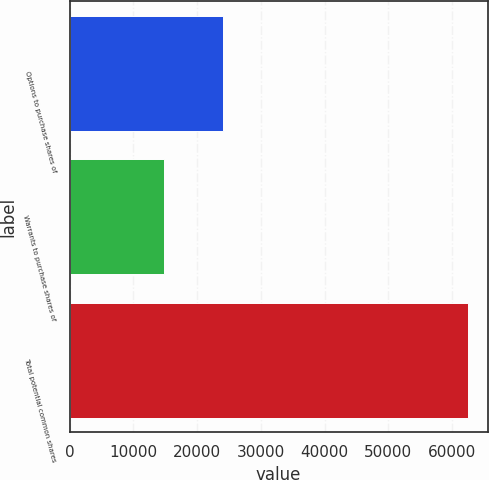<chart> <loc_0><loc_0><loc_500><loc_500><bar_chart><fcel>Options to purchase shares of<fcel>Warrants to purchase shares of<fcel>Total potential common shares<nl><fcel>24077<fcel>14717<fcel>62434<nl></chart> 